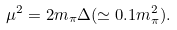Convert formula to latex. <formula><loc_0><loc_0><loc_500><loc_500>\mu ^ { 2 } = 2 m _ { \pi } \Delta ( \simeq 0 . 1 m _ { \pi } ^ { 2 } ) .</formula> 